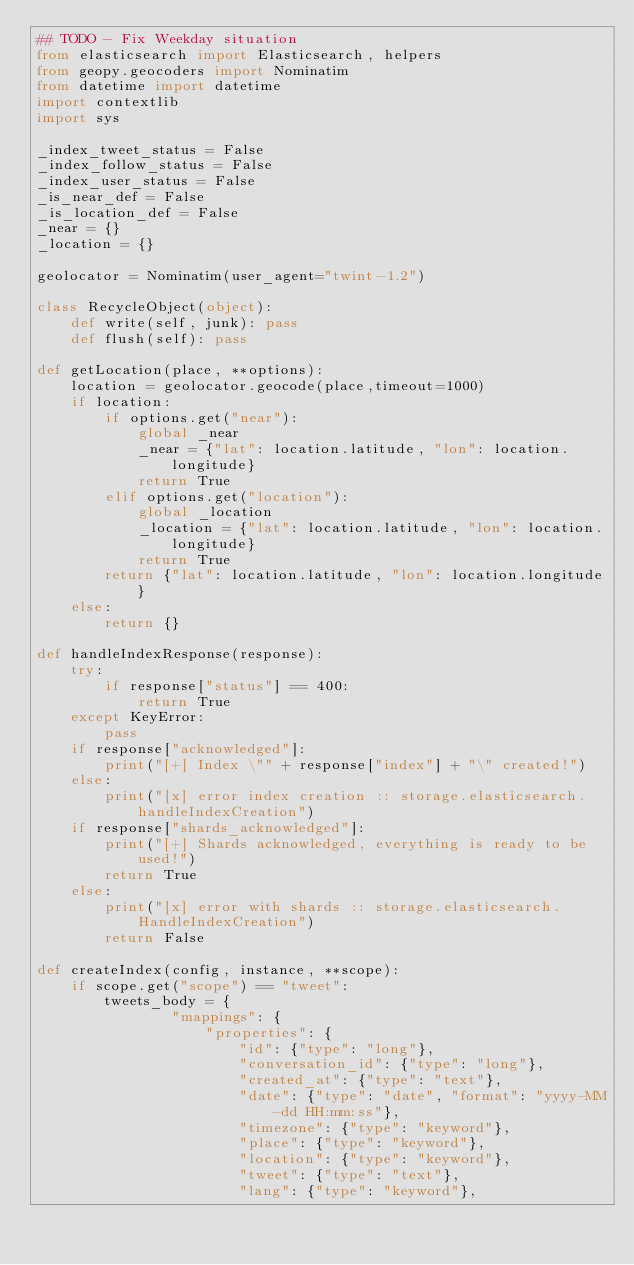Convert code to text. <code><loc_0><loc_0><loc_500><loc_500><_Python_>## TODO - Fix Weekday situation
from elasticsearch import Elasticsearch, helpers
from geopy.geocoders import Nominatim
from datetime import datetime
import contextlib
import sys

_index_tweet_status = False
_index_follow_status = False
_index_user_status = False
_is_near_def = False
_is_location_def = False
_near = {}
_location = {}

geolocator = Nominatim(user_agent="twint-1.2")

class RecycleObject(object):
    def write(self, junk): pass
    def flush(self): pass

def getLocation(place, **options):
    location = geolocator.geocode(place,timeout=1000)
    if location:
        if options.get("near"):
            global _near
            _near = {"lat": location.latitude, "lon": location.longitude}
            return True
        elif options.get("location"):
            global _location
            _location = {"lat": location.latitude, "lon": location.longitude}
            return True
        return {"lat": location.latitude, "lon": location.longitude}
    else:
        return {}

def handleIndexResponse(response):
    try:
        if response["status"] == 400:
            return True
    except KeyError:
        pass
    if response["acknowledged"]:
        print("[+] Index \"" + response["index"] + "\" created!")
    else:
        print("[x] error index creation :: storage.elasticsearch.handleIndexCreation")
    if response["shards_acknowledged"]:
        print("[+] Shards acknowledged, everything is ready to be used!")
        return True
    else:
        print("[x] error with shards :: storage.elasticsearch.HandleIndexCreation")
        return False

def createIndex(config, instance, **scope):
    if scope.get("scope") == "tweet":
        tweets_body = {
                "mappings": {
                    "properties": {
                        "id": {"type": "long"},
                        "conversation_id": {"type": "long"},
                        "created_at": {"type": "text"},
                        "date": {"type": "date", "format": "yyyy-MM-dd HH:mm:ss"},
                        "timezone": {"type": "keyword"},
                        "place": {"type": "keyword"},
                        "location": {"type": "keyword"},
                        "tweet": {"type": "text"},
                        "lang": {"type": "keyword"},</code> 